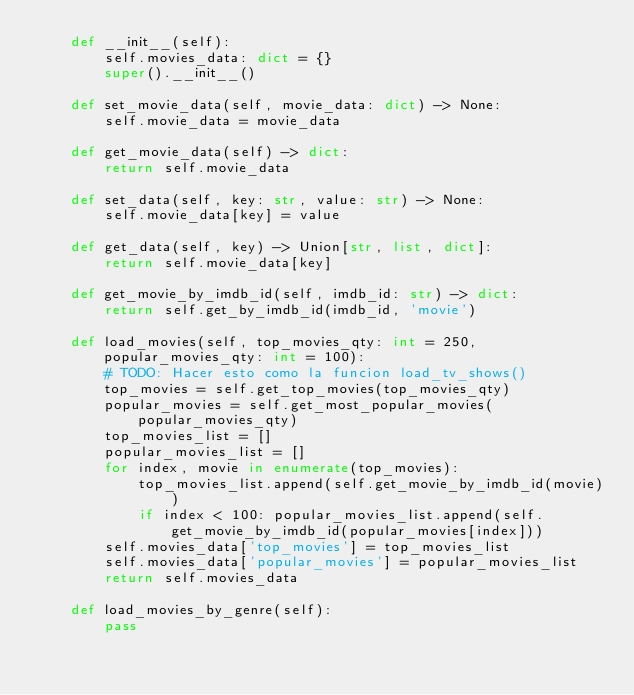Convert code to text. <code><loc_0><loc_0><loc_500><loc_500><_Python_>    def __init__(self):
        self.movies_data: dict = {}
        super().__init__()

    def set_movie_data(self, movie_data: dict) -> None:
        self.movie_data = movie_data

    def get_movie_data(self) -> dict:
        return self.movie_data

    def set_data(self, key: str, value: str) -> None:
        self.movie_data[key] = value

    def get_data(self, key) -> Union[str, list, dict]:
        return self.movie_data[key]

    def get_movie_by_imdb_id(self, imdb_id: str) -> dict:
        return self.get_by_imdb_id(imdb_id, 'movie')

    def load_movies(self, top_movies_qty: int = 250, popular_movies_qty: int = 100):
        # TODO: Hacer esto como la funcion load_tv_shows()
        top_movies = self.get_top_movies(top_movies_qty)
        popular_movies = self.get_most_popular_movies(popular_movies_qty)
        top_movies_list = []
        popular_movies_list = []
        for index, movie in enumerate(top_movies):
            top_movies_list.append(self.get_movie_by_imdb_id(movie))
            if index < 100: popular_movies_list.append(self.get_movie_by_imdb_id(popular_movies[index]))
        self.movies_data['top_movies'] = top_movies_list
        self.movies_data['popular_movies'] = popular_movies_list
        return self.movies_data

    def load_movies_by_genre(self):
        pass
</code> 